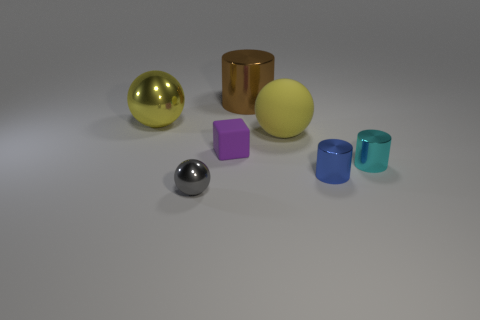Is the small rubber block the same color as the big rubber object?
Offer a terse response. No. The small thing that is to the left of the small cyan cylinder and behind the blue shiny cylinder is what color?
Your response must be concise. Purple. What number of cylinders are big blue metallic things or purple objects?
Your response must be concise. 0. Are there fewer tiny blue cylinders that are in front of the gray shiny ball than big gray rubber cylinders?
Make the answer very short. No. There is a big yellow thing that is the same material as the brown cylinder; what is its shape?
Make the answer very short. Sphere. What number of small metallic objects have the same color as the large cylinder?
Offer a very short reply. 0. What number of objects are tiny blue shiny cylinders or large metal things?
Your answer should be compact. 3. The small thing that is on the right side of the cylinder that is in front of the tiny cyan metal thing is made of what material?
Your answer should be very brief. Metal. Is there a green ball made of the same material as the blue cylinder?
Make the answer very short. No. There is a big thing behind the yellow object that is to the left of the rubber thing to the right of the purple matte object; what shape is it?
Offer a terse response. Cylinder. 